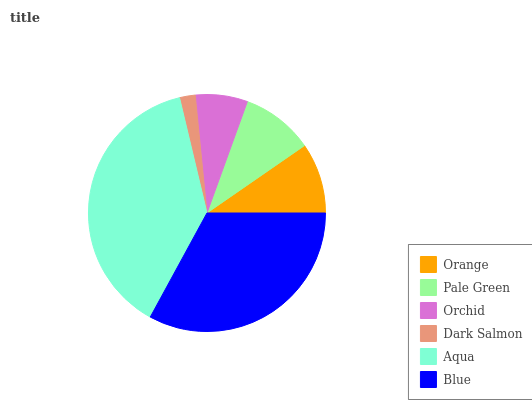Is Dark Salmon the minimum?
Answer yes or no. Yes. Is Aqua the maximum?
Answer yes or no. Yes. Is Pale Green the minimum?
Answer yes or no. No. Is Pale Green the maximum?
Answer yes or no. No. Is Pale Green greater than Orange?
Answer yes or no. Yes. Is Orange less than Pale Green?
Answer yes or no. Yes. Is Orange greater than Pale Green?
Answer yes or no. No. Is Pale Green less than Orange?
Answer yes or no. No. Is Pale Green the high median?
Answer yes or no. Yes. Is Orange the low median?
Answer yes or no. Yes. Is Blue the high median?
Answer yes or no. No. Is Blue the low median?
Answer yes or no. No. 